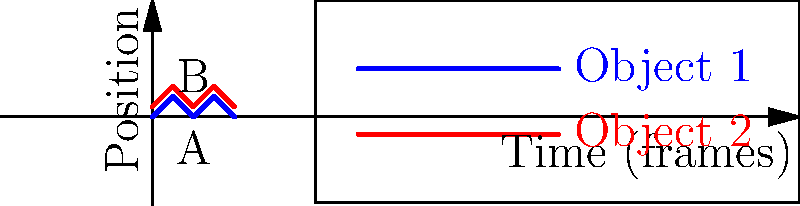In a computer vision system tracking two objects in a video sequence, the graph shows their vertical positions over time. What is the primary challenge in accurately determining the relative motion between objects A and B, given their oscillating patterns? To determine the relative motion between objects A and B, we need to consider several factors:

1. Pattern recognition: Both objects show an oscillating pattern, but with different amplitudes and a phase shift.

2. Frequency analysis: The oscillation frequency appears to be the same for both objects, completing two full cycles in 4 frames.

3. Amplitude difference: Object B (red line) has a consistently higher amplitude than Object A (blue line).

4. Phase shift: There is a phase difference between the two patterns, with Object B's peaks aligning with Object A's troughs.

5. Relative motion calculation: To determine relative motion, we need to consider the difference in position at each time point.

6. Temporal resolution: With only 4 frames of data, the temporal resolution is limited, making it challenging to accurately capture the continuous motion.

7. Potential occlusions: In real-world scenarios, objects may temporarily occlude each other, leading to missing data points.

8. Noise and measurement errors: Real tracking data often contains noise, which can affect the accuracy of motion analysis.

The primary challenge lies in accurately computing the relative motion given the oscillating patterns, limited temporal resolution, and potential real-world complications like occlusions and noise. The system needs to account for the phase shift and amplitude differences while also considering the limitations of the data available.
Answer: Accurately computing relative motion from oscillating patterns with limited temporal resolution 